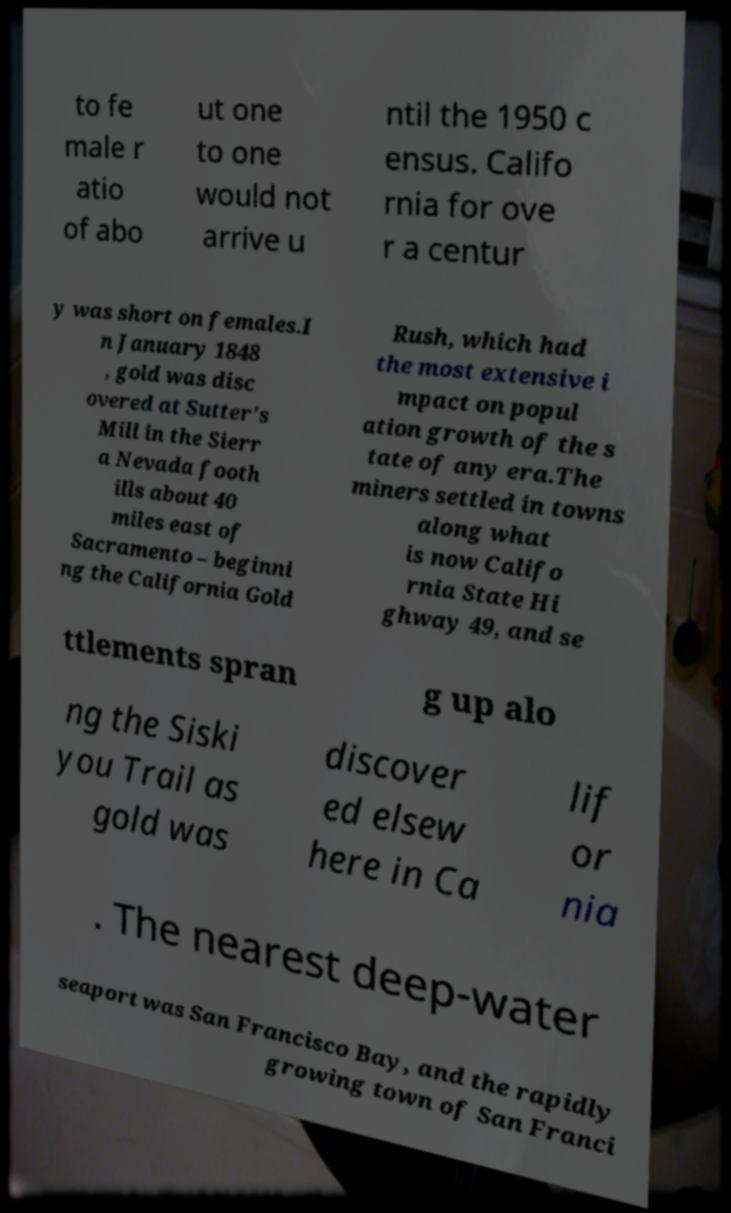Could you assist in decoding the text presented in this image and type it out clearly? to fe male r atio of abo ut one to one would not arrive u ntil the 1950 c ensus. Califo rnia for ove r a centur y was short on females.I n January 1848 , gold was disc overed at Sutter's Mill in the Sierr a Nevada footh ills about 40 miles east of Sacramento – beginni ng the California Gold Rush, which had the most extensive i mpact on popul ation growth of the s tate of any era.The miners settled in towns along what is now Califo rnia State Hi ghway 49, and se ttlements spran g up alo ng the Siski you Trail as gold was discover ed elsew here in Ca lif or nia . The nearest deep-water seaport was San Francisco Bay, and the rapidly growing town of San Franci 